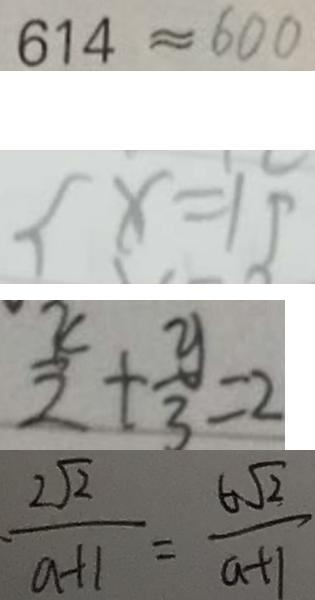Convert formula to latex. <formula><loc_0><loc_0><loc_500><loc_500>6 1 4 \approx 6 0 0 
 x = 1 5 
 \frac { x } { 2 } + \frac { y } { 3 } = 2 
 \cdot \frac { 2 \sqrt { 2 } } { a + 1 } = \frac { 6 \sqrt { 2 } } { a + 1 }</formula> 